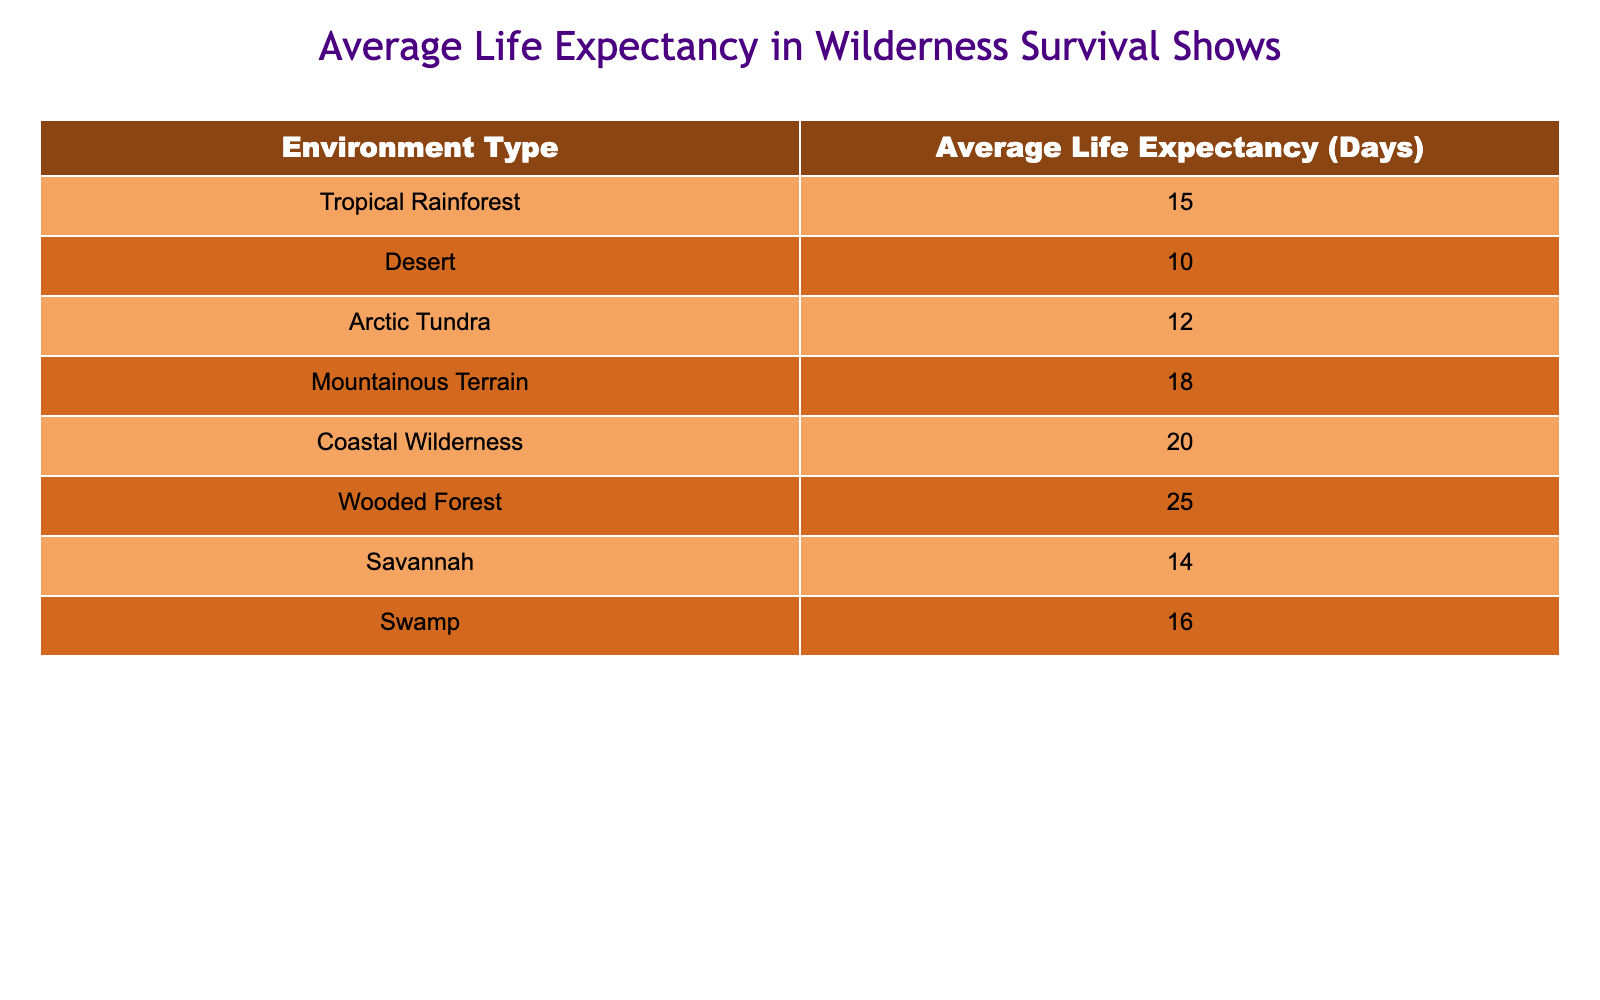What is the average life expectancy in Coastal Wilderness? The table shows the life expectancy for each environment type. The life expectancy for Coastal Wilderness is explicitly listed as 20 days.
Answer: 20 days What environment type has the lowest average life expectancy? By comparing the values in the table, the Desert environment has the lowest life expectancy of 10 days.
Answer: Desert What is the average life expectancy for environments located in wetland areas (Swamp and Coastal Wilderness)? The average life expectancy for Swamp is 16 days and Coastal Wilderness is 20 days. To find the average, we add these two values (16 + 20 = 36) and then divide by 2, resulting in 36 / 2 = 18 days.
Answer: 18 days Does the Coastal Wilderness have a higher average life expectancy than the Arctic Tundra? According to the table, Coastal Wilderness has an average life expectancy of 20 days, while Arctic Tundra has an average of 12 days. Therefore, 20 days is indeed greater than 12 days.
Answer: Yes What is the total life expectancy of participants in Mountainous Terrain and Savannah? The average life expectancy for Mountainous Terrain is 18 days and Savannah is 14 days. Adding these together gives 18 + 14 = 32 days as the total life expectancy for these two environments.
Answer: 32 days Which environment type has an average life expectancy that is greater than 15 days? Looking at the table, the environments with an average life expectancy greater than 15 days are Coastal Wilderness (20), Wooded Forest (25), and Mountainous Terrain (18).
Answer: Coastal Wilderness, Wooded Forest, Mountainous Terrain If we were to rank all environments from highest to lowest average life expectancy, what would be the first and last environments? By examining the available data, the environments in descending order are: Wooded Forest (25), Coastal Wilderness (20), Mountainous Terrain (18), Swamp (16), Savannah (14), Arctic Tundra (12), Tropical Rainforest (15), and Desert (10). Thus, the first is Wooded Forest and the last is Desert.
Answer: First: Wooded Forest, Last: Desert What is the difference in average life expectancy between Wooded Forest and Desert? Wooded Forest has an average life expectancy of 25 days and Desert has 10 days. The difference is calculated by subtracting these values: 25 - 10 = 15 days.
Answer: 15 days 